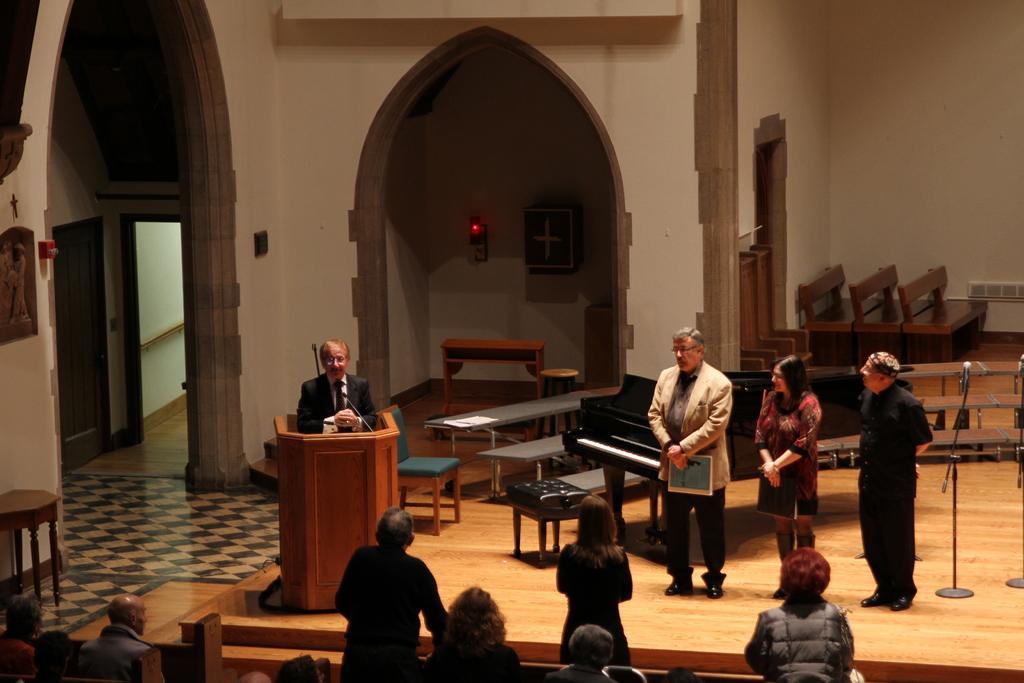Please provide a concise description of this image. In this image we can see the person standing in front of the podium. We can also see the persons standing. At the bottom we can see a few people. In the background we can see the tables, benches, mics with stands and also the chair. We can also see the light, door, a frame attached to the plain wall. 